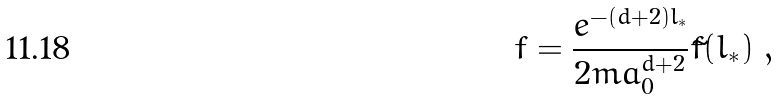<formula> <loc_0><loc_0><loc_500><loc_500>f = \frac { e ^ { - ( d + 2 ) l _ { * } } } { 2 m a _ { 0 } ^ { d + 2 } } \tilde { f } ( l _ { * } ) \ ,</formula> 